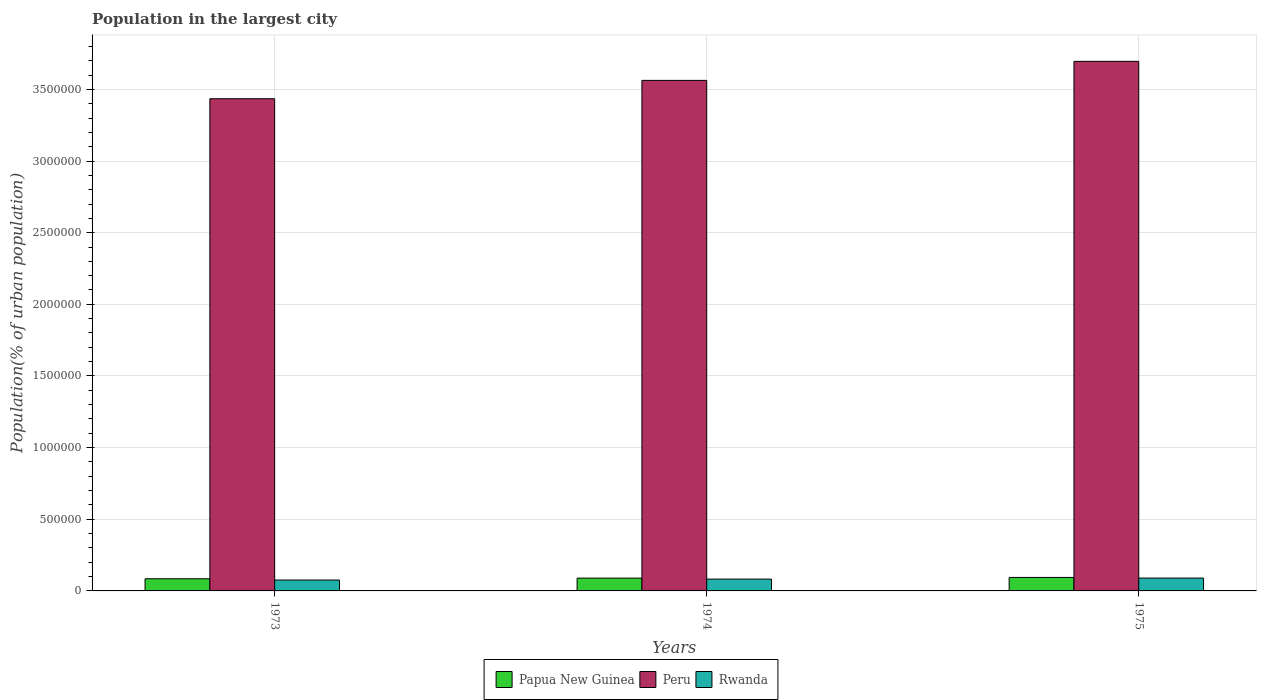How many different coloured bars are there?
Offer a terse response. 3. How many groups of bars are there?
Your response must be concise. 3. Are the number of bars on each tick of the X-axis equal?
Offer a very short reply. Yes. What is the label of the 3rd group of bars from the left?
Ensure brevity in your answer.  1975. What is the population in the largest city in Rwanda in 1974?
Offer a terse response. 8.25e+04. Across all years, what is the maximum population in the largest city in Papua New Guinea?
Keep it short and to the point. 9.42e+04. Across all years, what is the minimum population in the largest city in Peru?
Your response must be concise. 3.43e+06. In which year was the population in the largest city in Papua New Guinea maximum?
Ensure brevity in your answer.  1975. What is the total population in the largest city in Peru in the graph?
Provide a succinct answer. 1.07e+07. What is the difference between the population in the largest city in Rwanda in 1973 and that in 1974?
Give a very brief answer. -6546. What is the difference between the population in the largest city in Papua New Guinea in 1973 and the population in the largest city in Rwanda in 1974?
Your answer should be compact. 2360. What is the average population in the largest city in Peru per year?
Provide a short and direct response. 3.56e+06. In the year 1975, what is the difference between the population in the largest city in Papua New Guinea and population in the largest city in Peru?
Keep it short and to the point. -3.60e+06. What is the ratio of the population in the largest city in Peru in 1974 to that in 1975?
Offer a very short reply. 0.96. Is the population in the largest city in Papua New Guinea in 1973 less than that in 1975?
Give a very brief answer. Yes. What is the difference between the highest and the second highest population in the largest city in Peru?
Your response must be concise. 1.33e+05. What is the difference between the highest and the lowest population in the largest city in Peru?
Offer a terse response. 2.61e+05. Is the sum of the population in the largest city in Peru in 1973 and 1974 greater than the maximum population in the largest city in Rwanda across all years?
Your answer should be very brief. Yes. What does the 3rd bar from the left in 1974 represents?
Give a very brief answer. Rwanda. What does the 3rd bar from the right in 1975 represents?
Your answer should be very brief. Papua New Guinea. Is it the case that in every year, the sum of the population in the largest city in Rwanda and population in the largest city in Peru is greater than the population in the largest city in Papua New Guinea?
Your response must be concise. Yes. How many bars are there?
Provide a short and direct response. 9. Are the values on the major ticks of Y-axis written in scientific E-notation?
Your answer should be compact. No. Does the graph contain grids?
Your response must be concise. Yes. Where does the legend appear in the graph?
Make the answer very short. Bottom center. What is the title of the graph?
Give a very brief answer. Population in the largest city. What is the label or title of the X-axis?
Offer a terse response. Years. What is the label or title of the Y-axis?
Your response must be concise. Population(% of urban population). What is the Population(% of urban population) of Papua New Guinea in 1973?
Give a very brief answer. 8.48e+04. What is the Population(% of urban population) in Peru in 1973?
Your answer should be compact. 3.43e+06. What is the Population(% of urban population) of Rwanda in 1973?
Give a very brief answer. 7.59e+04. What is the Population(% of urban population) in Papua New Guinea in 1974?
Your answer should be compact. 8.94e+04. What is the Population(% of urban population) of Peru in 1974?
Your answer should be very brief. 3.56e+06. What is the Population(% of urban population) of Rwanda in 1974?
Your answer should be very brief. 8.25e+04. What is the Population(% of urban population) of Papua New Guinea in 1975?
Keep it short and to the point. 9.42e+04. What is the Population(% of urban population) of Peru in 1975?
Give a very brief answer. 3.70e+06. What is the Population(% of urban population) in Rwanda in 1975?
Offer a very short reply. 8.96e+04. Across all years, what is the maximum Population(% of urban population) of Papua New Guinea?
Ensure brevity in your answer.  9.42e+04. Across all years, what is the maximum Population(% of urban population) in Peru?
Provide a short and direct response. 3.70e+06. Across all years, what is the maximum Population(% of urban population) of Rwanda?
Make the answer very short. 8.96e+04. Across all years, what is the minimum Population(% of urban population) of Papua New Guinea?
Offer a very short reply. 8.48e+04. Across all years, what is the minimum Population(% of urban population) of Peru?
Your answer should be compact. 3.43e+06. Across all years, what is the minimum Population(% of urban population) in Rwanda?
Your response must be concise. 7.59e+04. What is the total Population(% of urban population) of Papua New Guinea in the graph?
Your answer should be compact. 2.68e+05. What is the total Population(% of urban population) of Peru in the graph?
Your response must be concise. 1.07e+07. What is the total Population(% of urban population) in Rwanda in the graph?
Provide a succinct answer. 2.48e+05. What is the difference between the Population(% of urban population) of Papua New Guinea in 1973 and that in 1974?
Provide a succinct answer. -4537. What is the difference between the Population(% of urban population) of Peru in 1973 and that in 1974?
Provide a short and direct response. -1.28e+05. What is the difference between the Population(% of urban population) in Rwanda in 1973 and that in 1974?
Make the answer very short. -6546. What is the difference between the Population(% of urban population) of Papua New Guinea in 1973 and that in 1975?
Keep it short and to the point. -9316. What is the difference between the Population(% of urban population) of Peru in 1973 and that in 1975?
Your response must be concise. -2.61e+05. What is the difference between the Population(% of urban population) in Rwanda in 1973 and that in 1975?
Offer a very short reply. -1.37e+04. What is the difference between the Population(% of urban population) of Papua New Guinea in 1974 and that in 1975?
Ensure brevity in your answer.  -4779. What is the difference between the Population(% of urban population) in Peru in 1974 and that in 1975?
Give a very brief answer. -1.33e+05. What is the difference between the Population(% of urban population) of Rwanda in 1974 and that in 1975?
Provide a short and direct response. -7111. What is the difference between the Population(% of urban population) in Papua New Guinea in 1973 and the Population(% of urban population) in Peru in 1974?
Offer a very short reply. -3.48e+06. What is the difference between the Population(% of urban population) in Papua New Guinea in 1973 and the Population(% of urban population) in Rwanda in 1974?
Your response must be concise. 2360. What is the difference between the Population(% of urban population) of Peru in 1973 and the Population(% of urban population) of Rwanda in 1974?
Ensure brevity in your answer.  3.35e+06. What is the difference between the Population(% of urban population) in Papua New Guinea in 1973 and the Population(% of urban population) in Peru in 1975?
Your answer should be compact. -3.61e+06. What is the difference between the Population(% of urban population) in Papua New Guinea in 1973 and the Population(% of urban population) in Rwanda in 1975?
Offer a very short reply. -4751. What is the difference between the Population(% of urban population) of Peru in 1973 and the Population(% of urban population) of Rwanda in 1975?
Your response must be concise. 3.35e+06. What is the difference between the Population(% of urban population) of Papua New Guinea in 1974 and the Population(% of urban population) of Peru in 1975?
Your answer should be compact. -3.61e+06. What is the difference between the Population(% of urban population) in Papua New Guinea in 1974 and the Population(% of urban population) in Rwanda in 1975?
Give a very brief answer. -214. What is the difference between the Population(% of urban population) of Peru in 1974 and the Population(% of urban population) of Rwanda in 1975?
Provide a short and direct response. 3.47e+06. What is the average Population(% of urban population) of Papua New Guinea per year?
Your response must be concise. 8.95e+04. What is the average Population(% of urban population) in Peru per year?
Offer a very short reply. 3.56e+06. What is the average Population(% of urban population) of Rwanda per year?
Keep it short and to the point. 8.27e+04. In the year 1973, what is the difference between the Population(% of urban population) in Papua New Guinea and Population(% of urban population) in Peru?
Ensure brevity in your answer.  -3.35e+06. In the year 1973, what is the difference between the Population(% of urban population) of Papua New Guinea and Population(% of urban population) of Rwanda?
Keep it short and to the point. 8906. In the year 1973, what is the difference between the Population(% of urban population) of Peru and Population(% of urban population) of Rwanda?
Your answer should be very brief. 3.36e+06. In the year 1974, what is the difference between the Population(% of urban population) in Papua New Guinea and Population(% of urban population) in Peru?
Your answer should be compact. -3.47e+06. In the year 1974, what is the difference between the Population(% of urban population) of Papua New Guinea and Population(% of urban population) of Rwanda?
Offer a terse response. 6897. In the year 1974, what is the difference between the Population(% of urban population) of Peru and Population(% of urban population) of Rwanda?
Provide a succinct answer. 3.48e+06. In the year 1975, what is the difference between the Population(% of urban population) in Papua New Guinea and Population(% of urban population) in Peru?
Provide a succinct answer. -3.60e+06. In the year 1975, what is the difference between the Population(% of urban population) of Papua New Guinea and Population(% of urban population) of Rwanda?
Your response must be concise. 4565. In the year 1975, what is the difference between the Population(% of urban population) in Peru and Population(% of urban population) in Rwanda?
Make the answer very short. 3.61e+06. What is the ratio of the Population(% of urban population) in Papua New Guinea in 1973 to that in 1974?
Your response must be concise. 0.95. What is the ratio of the Population(% of urban population) of Peru in 1973 to that in 1974?
Your response must be concise. 0.96. What is the ratio of the Population(% of urban population) of Rwanda in 1973 to that in 1974?
Keep it short and to the point. 0.92. What is the ratio of the Population(% of urban population) in Papua New Guinea in 1973 to that in 1975?
Make the answer very short. 0.9. What is the ratio of the Population(% of urban population) in Peru in 1973 to that in 1975?
Your response must be concise. 0.93. What is the ratio of the Population(% of urban population) of Rwanda in 1973 to that in 1975?
Make the answer very short. 0.85. What is the ratio of the Population(% of urban population) of Papua New Guinea in 1974 to that in 1975?
Keep it short and to the point. 0.95. What is the ratio of the Population(% of urban population) in Peru in 1974 to that in 1975?
Ensure brevity in your answer.  0.96. What is the ratio of the Population(% of urban population) of Rwanda in 1974 to that in 1975?
Your response must be concise. 0.92. What is the difference between the highest and the second highest Population(% of urban population) in Papua New Guinea?
Provide a succinct answer. 4779. What is the difference between the highest and the second highest Population(% of urban population) of Peru?
Your answer should be very brief. 1.33e+05. What is the difference between the highest and the second highest Population(% of urban population) in Rwanda?
Your answer should be compact. 7111. What is the difference between the highest and the lowest Population(% of urban population) in Papua New Guinea?
Keep it short and to the point. 9316. What is the difference between the highest and the lowest Population(% of urban population) in Peru?
Give a very brief answer. 2.61e+05. What is the difference between the highest and the lowest Population(% of urban population) of Rwanda?
Make the answer very short. 1.37e+04. 